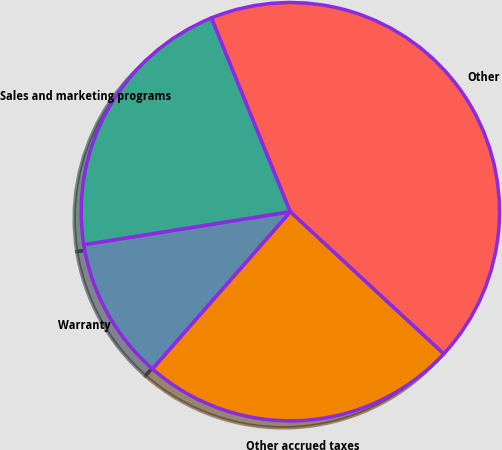Convert chart. <chart><loc_0><loc_0><loc_500><loc_500><pie_chart><fcel>Other accrued taxes<fcel>Warranty<fcel>Sales and marketing programs<fcel>Other<nl><fcel>24.57%<fcel>11.02%<fcel>21.37%<fcel>43.03%<nl></chart> 